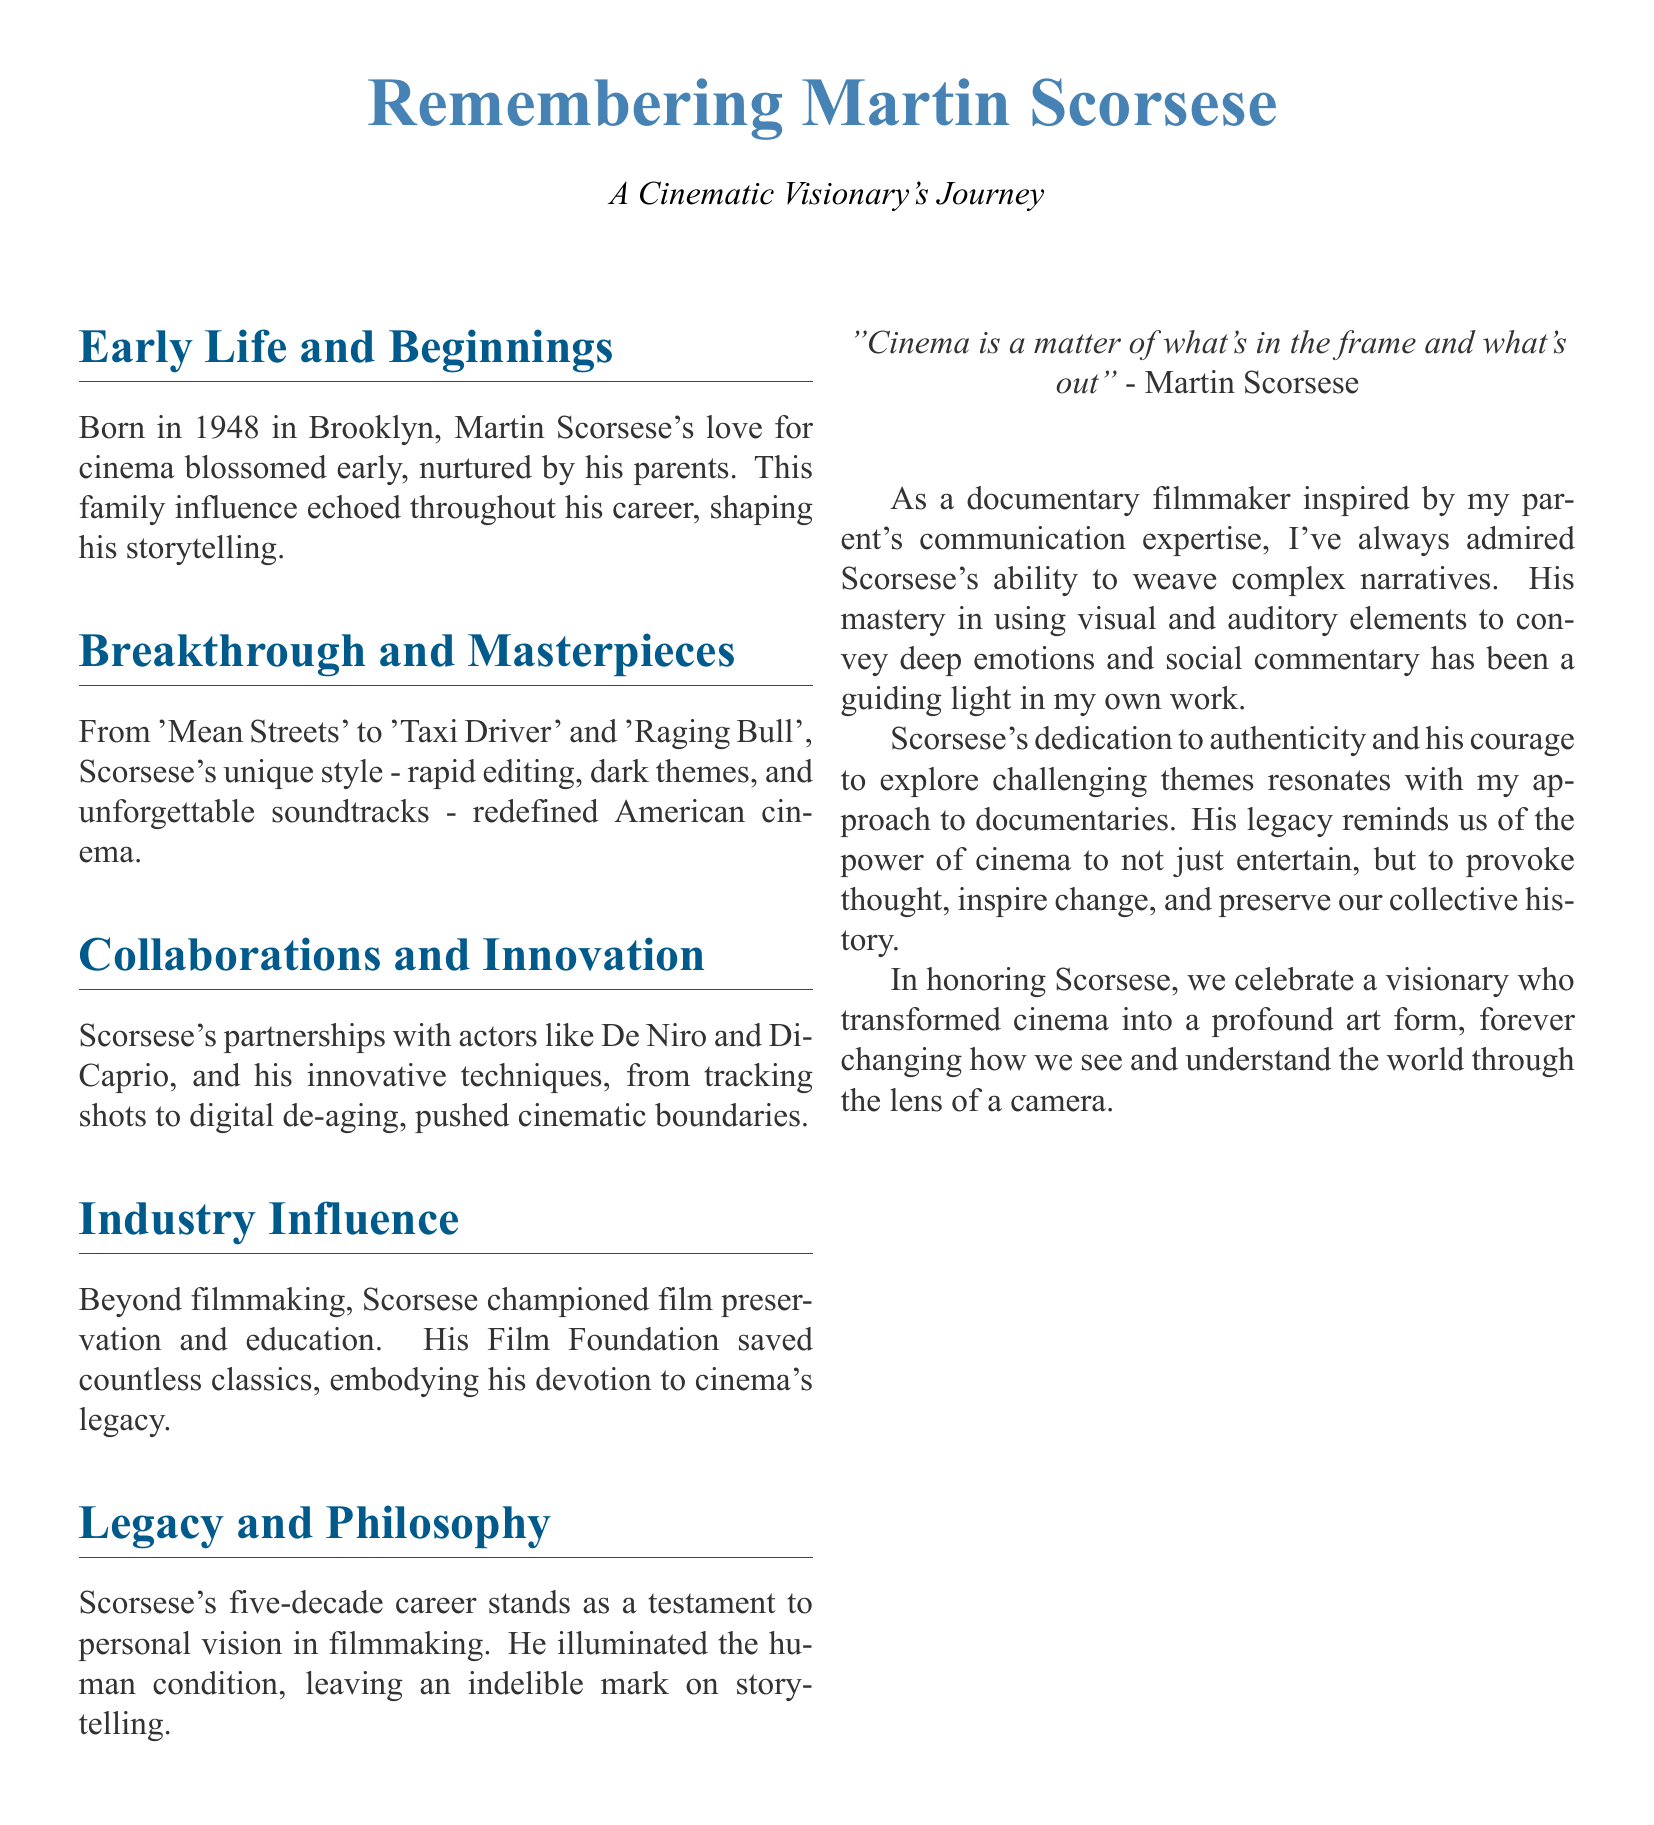What is Martin Scorsese's year of birth? The document states that Martin Scorsese was born in 1948.
Answer: 1948 Which film does the document mention as part of Scorsese's breakthrough works? The document lists 'Mean Streets', 'Taxi Driver', and 'Raging Bull' as breakthrough films.
Answer: Mean Streets What film preservation effort did Scorsese champion? The document refers to Scorsese's Film Foundation which saved countless classics.
Answer: Film Foundation What is a notable storytelling technique Scorsese used? The document mentions rapid editing as one of Scorsese's unique styles.
Answer: Rapid editing What does Scorsese's quote mention as important in cinema? Scorsese's quote in the document emphasizes what is in the frame and what is out.
Answer: What's in the frame and what's out How many decades did Scorsese's career span? The document highlights that Scorsese's career spans five decades.
Answer: Five decades What theme is Scorsese known for exploring? The document notes that Scorsese explored dark themes in his films.
Answer: Dark themes What role does the document attribute to Scorsese in the film industry? The document describes Scorsese as a champion of film preservation and education.
Answer: Champion of film preservation 